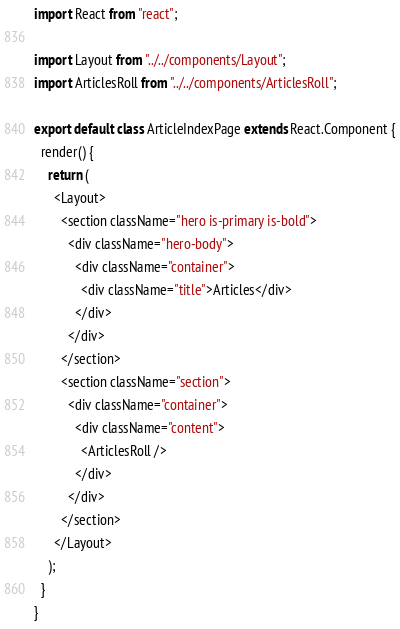<code> <loc_0><loc_0><loc_500><loc_500><_JavaScript_>import React from "react";

import Layout from "../../components/Layout";
import ArticlesRoll from "../../components/ArticlesRoll";

export default class ArticleIndexPage extends React.Component {
  render() {
    return (
      <Layout>
        <section className="hero is-primary is-bold">
          <div className="hero-body">
            <div className="container">
              <div className="title">Articles</div>
            </div>
          </div>
        </section>
        <section className="section">
          <div className="container">
            <div className="content">
              <ArticlesRoll />
            </div>
          </div>
        </section>
      </Layout>
    );
  }
}
</code> 